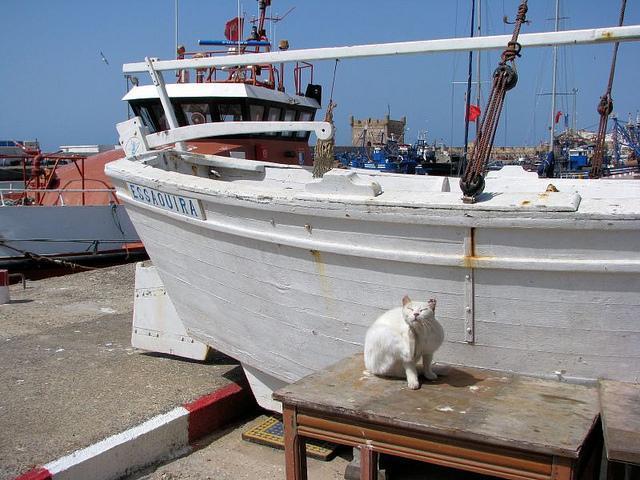How many dining tables are in the picture?
Give a very brief answer. 2. 